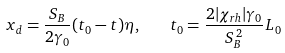Convert formula to latex. <formula><loc_0><loc_0><loc_500><loc_500>x _ { d } = \frac { S _ { B } } { 2 \gamma _ { 0 } } ( t _ { 0 } - t ) \eta , \quad t _ { 0 } = \frac { 2 | \chi _ { r h } | \gamma _ { 0 } } { S _ { B } ^ { \, 2 } } L _ { 0 }</formula> 